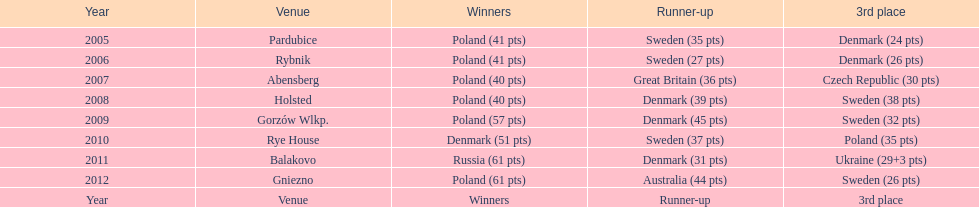After 2008 how many points total were scored by winners? 230. 